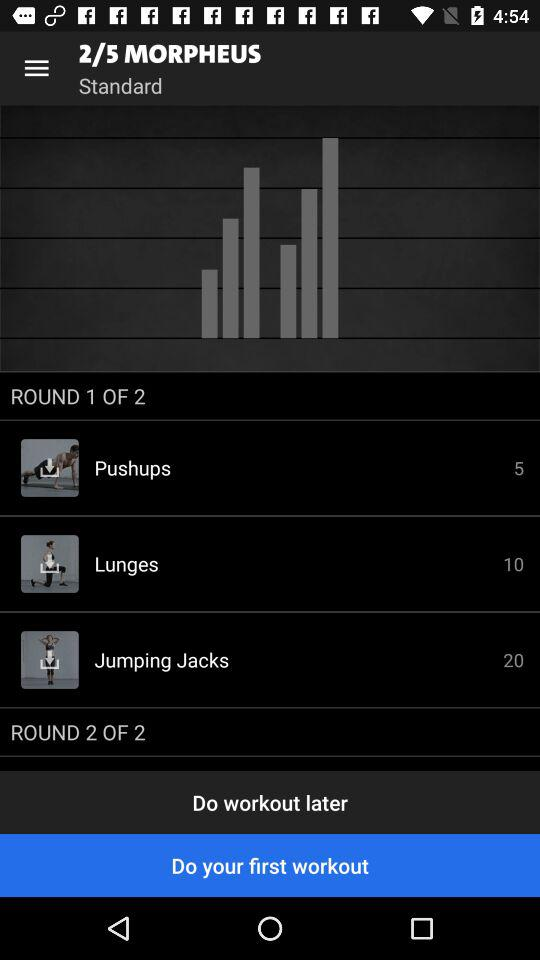How many rounds in total are there? There are 2 rounds in total. 